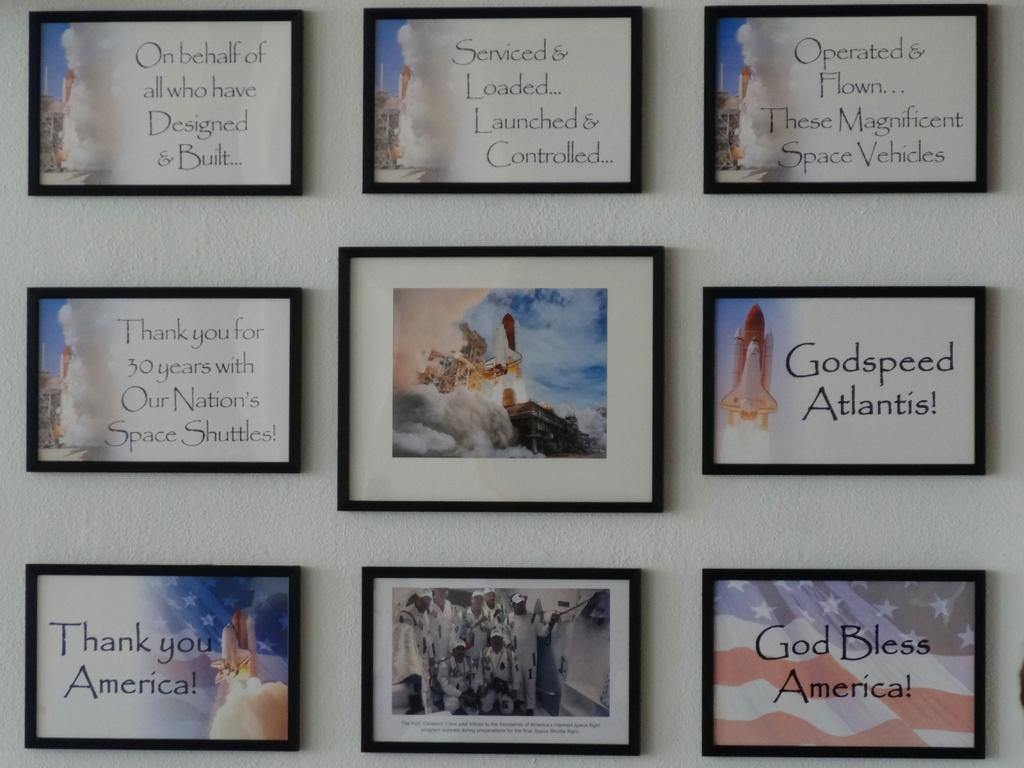Can you describe this image briefly? In this image there are a few photo frames on the wall. In the photo frames there are pictures and text. 